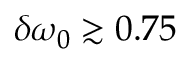Convert formula to latex. <formula><loc_0><loc_0><loc_500><loc_500>\delta \omega _ { 0 } \gtrsim 0 . 7 5 \</formula> 